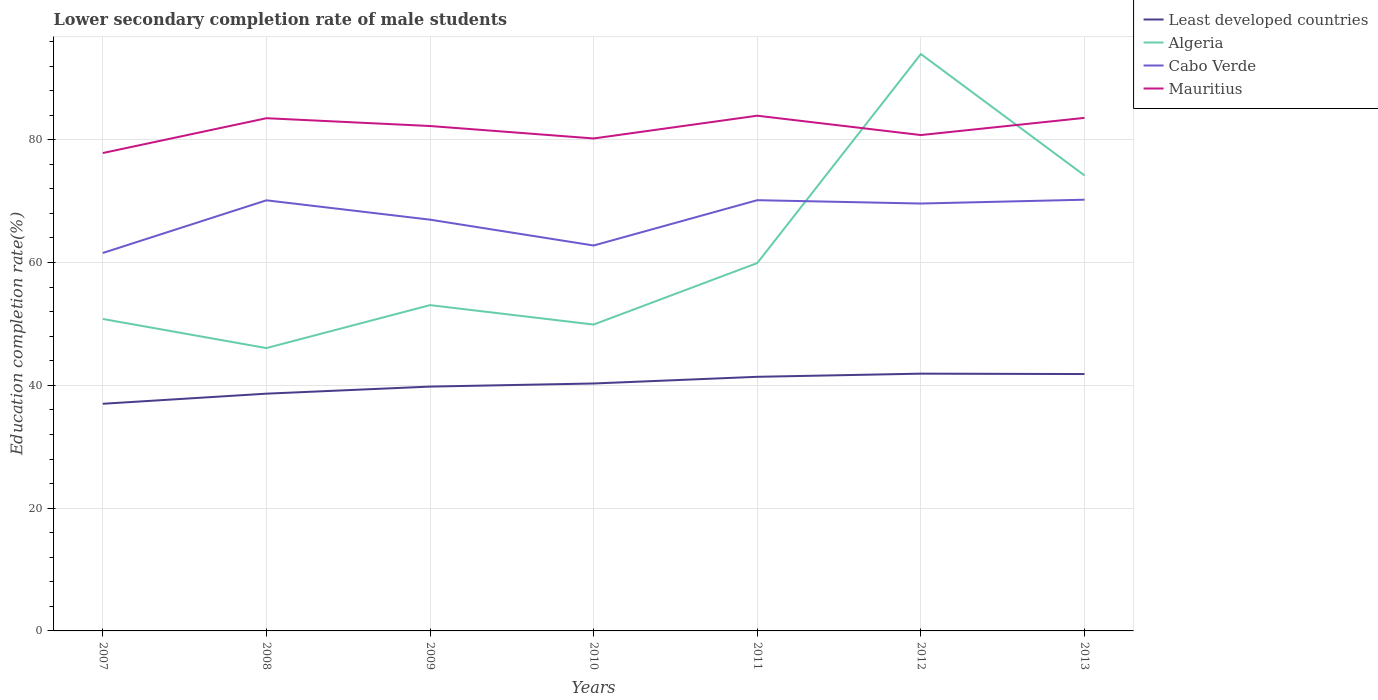Is the number of lines equal to the number of legend labels?
Offer a terse response. Yes. Across all years, what is the maximum lower secondary completion rate of male students in Mauritius?
Keep it short and to the point. 77.83. In which year was the lower secondary completion rate of male students in Algeria maximum?
Keep it short and to the point. 2008. What is the total lower secondary completion rate of male students in Mauritius in the graph?
Make the answer very short. -2.93. What is the difference between the highest and the second highest lower secondary completion rate of male students in Mauritius?
Give a very brief answer. 6.08. What is the difference between the highest and the lowest lower secondary completion rate of male students in Algeria?
Provide a succinct answer. 2. How many years are there in the graph?
Provide a succinct answer. 7. What is the difference between two consecutive major ticks on the Y-axis?
Offer a very short reply. 20. Are the values on the major ticks of Y-axis written in scientific E-notation?
Offer a terse response. No. Does the graph contain any zero values?
Offer a terse response. No. Does the graph contain grids?
Provide a succinct answer. Yes. Where does the legend appear in the graph?
Make the answer very short. Top right. How many legend labels are there?
Keep it short and to the point. 4. What is the title of the graph?
Offer a terse response. Lower secondary completion rate of male students. What is the label or title of the Y-axis?
Your response must be concise. Education completion rate(%). What is the Education completion rate(%) in Least developed countries in 2007?
Provide a short and direct response. 37. What is the Education completion rate(%) in Algeria in 2007?
Your answer should be compact. 50.81. What is the Education completion rate(%) of Cabo Verde in 2007?
Provide a short and direct response. 61.55. What is the Education completion rate(%) of Mauritius in 2007?
Your answer should be very brief. 77.83. What is the Education completion rate(%) in Least developed countries in 2008?
Ensure brevity in your answer.  38.64. What is the Education completion rate(%) in Algeria in 2008?
Provide a succinct answer. 46.07. What is the Education completion rate(%) of Cabo Verde in 2008?
Provide a short and direct response. 70.13. What is the Education completion rate(%) of Mauritius in 2008?
Keep it short and to the point. 83.51. What is the Education completion rate(%) of Least developed countries in 2009?
Keep it short and to the point. 39.79. What is the Education completion rate(%) of Algeria in 2009?
Keep it short and to the point. 53.06. What is the Education completion rate(%) of Cabo Verde in 2009?
Provide a succinct answer. 66.98. What is the Education completion rate(%) of Mauritius in 2009?
Your answer should be compact. 82.24. What is the Education completion rate(%) of Least developed countries in 2010?
Keep it short and to the point. 40.3. What is the Education completion rate(%) of Algeria in 2010?
Provide a succinct answer. 49.9. What is the Education completion rate(%) in Cabo Verde in 2010?
Keep it short and to the point. 62.77. What is the Education completion rate(%) of Mauritius in 2010?
Provide a short and direct response. 80.21. What is the Education completion rate(%) of Least developed countries in 2011?
Make the answer very short. 41.39. What is the Education completion rate(%) in Algeria in 2011?
Make the answer very short. 59.91. What is the Education completion rate(%) in Cabo Verde in 2011?
Ensure brevity in your answer.  70.15. What is the Education completion rate(%) in Mauritius in 2011?
Keep it short and to the point. 83.91. What is the Education completion rate(%) of Least developed countries in 2012?
Provide a short and direct response. 41.9. What is the Education completion rate(%) in Algeria in 2012?
Provide a short and direct response. 93.95. What is the Education completion rate(%) of Cabo Verde in 2012?
Ensure brevity in your answer.  69.61. What is the Education completion rate(%) in Mauritius in 2012?
Your response must be concise. 80.76. What is the Education completion rate(%) of Least developed countries in 2013?
Provide a short and direct response. 41.84. What is the Education completion rate(%) of Algeria in 2013?
Offer a very short reply. 74.19. What is the Education completion rate(%) of Cabo Verde in 2013?
Your response must be concise. 70.23. What is the Education completion rate(%) of Mauritius in 2013?
Offer a very short reply. 83.56. Across all years, what is the maximum Education completion rate(%) in Least developed countries?
Provide a succinct answer. 41.9. Across all years, what is the maximum Education completion rate(%) in Algeria?
Provide a succinct answer. 93.95. Across all years, what is the maximum Education completion rate(%) in Cabo Verde?
Your answer should be compact. 70.23. Across all years, what is the maximum Education completion rate(%) of Mauritius?
Ensure brevity in your answer.  83.91. Across all years, what is the minimum Education completion rate(%) in Least developed countries?
Keep it short and to the point. 37. Across all years, what is the minimum Education completion rate(%) of Algeria?
Offer a terse response. 46.07. Across all years, what is the minimum Education completion rate(%) of Cabo Verde?
Offer a terse response. 61.55. Across all years, what is the minimum Education completion rate(%) of Mauritius?
Provide a succinct answer. 77.83. What is the total Education completion rate(%) in Least developed countries in the graph?
Offer a terse response. 280.86. What is the total Education completion rate(%) in Algeria in the graph?
Offer a very short reply. 427.9. What is the total Education completion rate(%) of Cabo Verde in the graph?
Give a very brief answer. 471.44. What is the total Education completion rate(%) in Mauritius in the graph?
Provide a succinct answer. 572.02. What is the difference between the Education completion rate(%) in Least developed countries in 2007 and that in 2008?
Provide a short and direct response. -1.65. What is the difference between the Education completion rate(%) in Algeria in 2007 and that in 2008?
Give a very brief answer. 4.74. What is the difference between the Education completion rate(%) of Cabo Verde in 2007 and that in 2008?
Provide a succinct answer. -8.58. What is the difference between the Education completion rate(%) of Mauritius in 2007 and that in 2008?
Your answer should be compact. -5.67. What is the difference between the Education completion rate(%) of Least developed countries in 2007 and that in 2009?
Provide a succinct answer. -2.8. What is the difference between the Education completion rate(%) of Algeria in 2007 and that in 2009?
Keep it short and to the point. -2.26. What is the difference between the Education completion rate(%) in Cabo Verde in 2007 and that in 2009?
Offer a very short reply. -5.43. What is the difference between the Education completion rate(%) of Mauritius in 2007 and that in 2009?
Give a very brief answer. -4.4. What is the difference between the Education completion rate(%) of Least developed countries in 2007 and that in 2010?
Your answer should be very brief. -3.31. What is the difference between the Education completion rate(%) in Algeria in 2007 and that in 2010?
Offer a very short reply. 0.91. What is the difference between the Education completion rate(%) in Cabo Verde in 2007 and that in 2010?
Keep it short and to the point. -1.22. What is the difference between the Education completion rate(%) of Mauritius in 2007 and that in 2010?
Your response must be concise. -2.38. What is the difference between the Education completion rate(%) in Least developed countries in 2007 and that in 2011?
Make the answer very short. -4.39. What is the difference between the Education completion rate(%) of Algeria in 2007 and that in 2011?
Provide a succinct answer. -9.1. What is the difference between the Education completion rate(%) of Cabo Verde in 2007 and that in 2011?
Give a very brief answer. -8.6. What is the difference between the Education completion rate(%) of Mauritius in 2007 and that in 2011?
Your answer should be compact. -6.08. What is the difference between the Education completion rate(%) of Least developed countries in 2007 and that in 2012?
Offer a very short reply. -4.91. What is the difference between the Education completion rate(%) of Algeria in 2007 and that in 2012?
Provide a succinct answer. -43.15. What is the difference between the Education completion rate(%) in Cabo Verde in 2007 and that in 2012?
Ensure brevity in your answer.  -8.06. What is the difference between the Education completion rate(%) of Mauritius in 2007 and that in 2012?
Offer a very short reply. -2.93. What is the difference between the Education completion rate(%) in Least developed countries in 2007 and that in 2013?
Provide a short and direct response. -4.84. What is the difference between the Education completion rate(%) of Algeria in 2007 and that in 2013?
Provide a succinct answer. -23.38. What is the difference between the Education completion rate(%) of Cabo Verde in 2007 and that in 2013?
Make the answer very short. -8.68. What is the difference between the Education completion rate(%) of Mauritius in 2007 and that in 2013?
Your answer should be compact. -5.73. What is the difference between the Education completion rate(%) in Least developed countries in 2008 and that in 2009?
Give a very brief answer. -1.15. What is the difference between the Education completion rate(%) in Algeria in 2008 and that in 2009?
Provide a short and direct response. -7. What is the difference between the Education completion rate(%) in Cabo Verde in 2008 and that in 2009?
Provide a succinct answer. 3.15. What is the difference between the Education completion rate(%) in Mauritius in 2008 and that in 2009?
Make the answer very short. 1.27. What is the difference between the Education completion rate(%) in Least developed countries in 2008 and that in 2010?
Give a very brief answer. -1.66. What is the difference between the Education completion rate(%) of Algeria in 2008 and that in 2010?
Your answer should be compact. -3.83. What is the difference between the Education completion rate(%) of Cabo Verde in 2008 and that in 2010?
Offer a terse response. 7.36. What is the difference between the Education completion rate(%) of Mauritius in 2008 and that in 2010?
Ensure brevity in your answer.  3.3. What is the difference between the Education completion rate(%) in Least developed countries in 2008 and that in 2011?
Make the answer very short. -2.75. What is the difference between the Education completion rate(%) in Algeria in 2008 and that in 2011?
Provide a short and direct response. -13.85. What is the difference between the Education completion rate(%) of Cabo Verde in 2008 and that in 2011?
Your response must be concise. -0.02. What is the difference between the Education completion rate(%) in Mauritius in 2008 and that in 2011?
Ensure brevity in your answer.  -0.41. What is the difference between the Education completion rate(%) of Least developed countries in 2008 and that in 2012?
Your answer should be compact. -3.26. What is the difference between the Education completion rate(%) of Algeria in 2008 and that in 2012?
Keep it short and to the point. -47.89. What is the difference between the Education completion rate(%) in Cabo Verde in 2008 and that in 2012?
Keep it short and to the point. 0.52. What is the difference between the Education completion rate(%) of Mauritius in 2008 and that in 2012?
Provide a short and direct response. 2.74. What is the difference between the Education completion rate(%) in Least developed countries in 2008 and that in 2013?
Provide a short and direct response. -3.2. What is the difference between the Education completion rate(%) of Algeria in 2008 and that in 2013?
Make the answer very short. -28.13. What is the difference between the Education completion rate(%) of Cabo Verde in 2008 and that in 2013?
Provide a short and direct response. -0.1. What is the difference between the Education completion rate(%) in Mauritius in 2008 and that in 2013?
Offer a terse response. -0.05. What is the difference between the Education completion rate(%) in Least developed countries in 2009 and that in 2010?
Give a very brief answer. -0.51. What is the difference between the Education completion rate(%) of Algeria in 2009 and that in 2010?
Your answer should be very brief. 3.16. What is the difference between the Education completion rate(%) in Cabo Verde in 2009 and that in 2010?
Offer a terse response. 4.21. What is the difference between the Education completion rate(%) in Mauritius in 2009 and that in 2010?
Provide a short and direct response. 2.03. What is the difference between the Education completion rate(%) in Least developed countries in 2009 and that in 2011?
Provide a short and direct response. -1.59. What is the difference between the Education completion rate(%) of Algeria in 2009 and that in 2011?
Ensure brevity in your answer.  -6.85. What is the difference between the Education completion rate(%) of Cabo Verde in 2009 and that in 2011?
Your response must be concise. -3.17. What is the difference between the Education completion rate(%) in Mauritius in 2009 and that in 2011?
Ensure brevity in your answer.  -1.68. What is the difference between the Education completion rate(%) of Least developed countries in 2009 and that in 2012?
Offer a terse response. -2.11. What is the difference between the Education completion rate(%) in Algeria in 2009 and that in 2012?
Ensure brevity in your answer.  -40.89. What is the difference between the Education completion rate(%) of Cabo Verde in 2009 and that in 2012?
Offer a terse response. -2.63. What is the difference between the Education completion rate(%) of Mauritius in 2009 and that in 2012?
Your response must be concise. 1.47. What is the difference between the Education completion rate(%) of Least developed countries in 2009 and that in 2013?
Offer a very short reply. -2.04. What is the difference between the Education completion rate(%) in Algeria in 2009 and that in 2013?
Offer a terse response. -21.13. What is the difference between the Education completion rate(%) in Cabo Verde in 2009 and that in 2013?
Your answer should be compact. -3.25. What is the difference between the Education completion rate(%) in Mauritius in 2009 and that in 2013?
Offer a very short reply. -1.32. What is the difference between the Education completion rate(%) in Least developed countries in 2010 and that in 2011?
Offer a terse response. -1.09. What is the difference between the Education completion rate(%) of Algeria in 2010 and that in 2011?
Provide a short and direct response. -10.01. What is the difference between the Education completion rate(%) of Cabo Verde in 2010 and that in 2011?
Ensure brevity in your answer.  -7.38. What is the difference between the Education completion rate(%) in Mauritius in 2010 and that in 2011?
Ensure brevity in your answer.  -3.71. What is the difference between the Education completion rate(%) in Least developed countries in 2010 and that in 2012?
Offer a very short reply. -1.6. What is the difference between the Education completion rate(%) in Algeria in 2010 and that in 2012?
Provide a short and direct response. -44.05. What is the difference between the Education completion rate(%) in Cabo Verde in 2010 and that in 2012?
Keep it short and to the point. -6.84. What is the difference between the Education completion rate(%) in Mauritius in 2010 and that in 2012?
Provide a succinct answer. -0.56. What is the difference between the Education completion rate(%) of Least developed countries in 2010 and that in 2013?
Ensure brevity in your answer.  -1.54. What is the difference between the Education completion rate(%) of Algeria in 2010 and that in 2013?
Provide a succinct answer. -24.29. What is the difference between the Education completion rate(%) of Cabo Verde in 2010 and that in 2013?
Give a very brief answer. -7.46. What is the difference between the Education completion rate(%) of Mauritius in 2010 and that in 2013?
Give a very brief answer. -3.35. What is the difference between the Education completion rate(%) of Least developed countries in 2011 and that in 2012?
Provide a succinct answer. -0.51. What is the difference between the Education completion rate(%) in Algeria in 2011 and that in 2012?
Your response must be concise. -34.04. What is the difference between the Education completion rate(%) of Cabo Verde in 2011 and that in 2012?
Give a very brief answer. 0.54. What is the difference between the Education completion rate(%) of Mauritius in 2011 and that in 2012?
Offer a very short reply. 3.15. What is the difference between the Education completion rate(%) in Least developed countries in 2011 and that in 2013?
Make the answer very short. -0.45. What is the difference between the Education completion rate(%) in Algeria in 2011 and that in 2013?
Ensure brevity in your answer.  -14.28. What is the difference between the Education completion rate(%) of Cabo Verde in 2011 and that in 2013?
Offer a terse response. -0.08. What is the difference between the Education completion rate(%) of Mauritius in 2011 and that in 2013?
Keep it short and to the point. 0.35. What is the difference between the Education completion rate(%) in Least developed countries in 2012 and that in 2013?
Keep it short and to the point. 0.06. What is the difference between the Education completion rate(%) in Algeria in 2012 and that in 2013?
Provide a succinct answer. 19.76. What is the difference between the Education completion rate(%) of Cabo Verde in 2012 and that in 2013?
Your response must be concise. -0.62. What is the difference between the Education completion rate(%) in Mauritius in 2012 and that in 2013?
Your answer should be compact. -2.8. What is the difference between the Education completion rate(%) of Least developed countries in 2007 and the Education completion rate(%) of Algeria in 2008?
Ensure brevity in your answer.  -9.07. What is the difference between the Education completion rate(%) of Least developed countries in 2007 and the Education completion rate(%) of Cabo Verde in 2008?
Offer a terse response. -33.14. What is the difference between the Education completion rate(%) of Least developed countries in 2007 and the Education completion rate(%) of Mauritius in 2008?
Your response must be concise. -46.51. What is the difference between the Education completion rate(%) of Algeria in 2007 and the Education completion rate(%) of Cabo Verde in 2008?
Your answer should be compact. -19.32. What is the difference between the Education completion rate(%) of Algeria in 2007 and the Education completion rate(%) of Mauritius in 2008?
Your answer should be compact. -32.7. What is the difference between the Education completion rate(%) of Cabo Verde in 2007 and the Education completion rate(%) of Mauritius in 2008?
Provide a short and direct response. -21.95. What is the difference between the Education completion rate(%) in Least developed countries in 2007 and the Education completion rate(%) in Algeria in 2009?
Your response must be concise. -16.07. What is the difference between the Education completion rate(%) of Least developed countries in 2007 and the Education completion rate(%) of Cabo Verde in 2009?
Offer a terse response. -29.99. What is the difference between the Education completion rate(%) in Least developed countries in 2007 and the Education completion rate(%) in Mauritius in 2009?
Offer a very short reply. -45.24. What is the difference between the Education completion rate(%) in Algeria in 2007 and the Education completion rate(%) in Cabo Verde in 2009?
Your response must be concise. -16.17. What is the difference between the Education completion rate(%) of Algeria in 2007 and the Education completion rate(%) of Mauritius in 2009?
Provide a short and direct response. -31.43. What is the difference between the Education completion rate(%) of Cabo Verde in 2007 and the Education completion rate(%) of Mauritius in 2009?
Provide a short and direct response. -20.68. What is the difference between the Education completion rate(%) of Least developed countries in 2007 and the Education completion rate(%) of Algeria in 2010?
Your response must be concise. -12.9. What is the difference between the Education completion rate(%) of Least developed countries in 2007 and the Education completion rate(%) of Cabo Verde in 2010?
Your answer should be compact. -25.78. What is the difference between the Education completion rate(%) in Least developed countries in 2007 and the Education completion rate(%) in Mauritius in 2010?
Provide a short and direct response. -43.21. What is the difference between the Education completion rate(%) of Algeria in 2007 and the Education completion rate(%) of Cabo Verde in 2010?
Your answer should be very brief. -11.97. What is the difference between the Education completion rate(%) of Algeria in 2007 and the Education completion rate(%) of Mauritius in 2010?
Provide a succinct answer. -29.4. What is the difference between the Education completion rate(%) in Cabo Verde in 2007 and the Education completion rate(%) in Mauritius in 2010?
Your response must be concise. -18.65. What is the difference between the Education completion rate(%) of Least developed countries in 2007 and the Education completion rate(%) of Algeria in 2011?
Offer a terse response. -22.92. What is the difference between the Education completion rate(%) in Least developed countries in 2007 and the Education completion rate(%) in Cabo Verde in 2011?
Keep it short and to the point. -33.16. What is the difference between the Education completion rate(%) of Least developed countries in 2007 and the Education completion rate(%) of Mauritius in 2011?
Give a very brief answer. -46.92. What is the difference between the Education completion rate(%) of Algeria in 2007 and the Education completion rate(%) of Cabo Verde in 2011?
Ensure brevity in your answer.  -19.35. What is the difference between the Education completion rate(%) of Algeria in 2007 and the Education completion rate(%) of Mauritius in 2011?
Provide a short and direct response. -33.11. What is the difference between the Education completion rate(%) of Cabo Verde in 2007 and the Education completion rate(%) of Mauritius in 2011?
Offer a very short reply. -22.36. What is the difference between the Education completion rate(%) of Least developed countries in 2007 and the Education completion rate(%) of Algeria in 2012?
Make the answer very short. -56.96. What is the difference between the Education completion rate(%) of Least developed countries in 2007 and the Education completion rate(%) of Cabo Verde in 2012?
Provide a succinct answer. -32.61. What is the difference between the Education completion rate(%) of Least developed countries in 2007 and the Education completion rate(%) of Mauritius in 2012?
Your response must be concise. -43.77. What is the difference between the Education completion rate(%) of Algeria in 2007 and the Education completion rate(%) of Cabo Verde in 2012?
Keep it short and to the point. -18.8. What is the difference between the Education completion rate(%) in Algeria in 2007 and the Education completion rate(%) in Mauritius in 2012?
Make the answer very short. -29.96. What is the difference between the Education completion rate(%) in Cabo Verde in 2007 and the Education completion rate(%) in Mauritius in 2012?
Offer a very short reply. -19.21. What is the difference between the Education completion rate(%) in Least developed countries in 2007 and the Education completion rate(%) in Algeria in 2013?
Offer a very short reply. -37.2. What is the difference between the Education completion rate(%) in Least developed countries in 2007 and the Education completion rate(%) in Cabo Verde in 2013?
Provide a succinct answer. -33.24. What is the difference between the Education completion rate(%) of Least developed countries in 2007 and the Education completion rate(%) of Mauritius in 2013?
Keep it short and to the point. -46.56. What is the difference between the Education completion rate(%) in Algeria in 2007 and the Education completion rate(%) in Cabo Verde in 2013?
Your response must be concise. -19.42. What is the difference between the Education completion rate(%) in Algeria in 2007 and the Education completion rate(%) in Mauritius in 2013?
Offer a terse response. -32.75. What is the difference between the Education completion rate(%) in Cabo Verde in 2007 and the Education completion rate(%) in Mauritius in 2013?
Provide a short and direct response. -22.01. What is the difference between the Education completion rate(%) of Least developed countries in 2008 and the Education completion rate(%) of Algeria in 2009?
Give a very brief answer. -14.42. What is the difference between the Education completion rate(%) in Least developed countries in 2008 and the Education completion rate(%) in Cabo Verde in 2009?
Provide a short and direct response. -28.34. What is the difference between the Education completion rate(%) of Least developed countries in 2008 and the Education completion rate(%) of Mauritius in 2009?
Your response must be concise. -43.59. What is the difference between the Education completion rate(%) in Algeria in 2008 and the Education completion rate(%) in Cabo Verde in 2009?
Your response must be concise. -20.92. What is the difference between the Education completion rate(%) of Algeria in 2008 and the Education completion rate(%) of Mauritius in 2009?
Make the answer very short. -36.17. What is the difference between the Education completion rate(%) in Cabo Verde in 2008 and the Education completion rate(%) in Mauritius in 2009?
Provide a succinct answer. -12.1. What is the difference between the Education completion rate(%) in Least developed countries in 2008 and the Education completion rate(%) in Algeria in 2010?
Keep it short and to the point. -11.26. What is the difference between the Education completion rate(%) in Least developed countries in 2008 and the Education completion rate(%) in Cabo Verde in 2010?
Offer a terse response. -24.13. What is the difference between the Education completion rate(%) of Least developed countries in 2008 and the Education completion rate(%) of Mauritius in 2010?
Give a very brief answer. -41.57. What is the difference between the Education completion rate(%) in Algeria in 2008 and the Education completion rate(%) in Cabo Verde in 2010?
Offer a very short reply. -16.71. What is the difference between the Education completion rate(%) in Algeria in 2008 and the Education completion rate(%) in Mauritius in 2010?
Offer a very short reply. -34.14. What is the difference between the Education completion rate(%) in Cabo Verde in 2008 and the Education completion rate(%) in Mauritius in 2010?
Make the answer very short. -10.08. What is the difference between the Education completion rate(%) in Least developed countries in 2008 and the Education completion rate(%) in Algeria in 2011?
Keep it short and to the point. -21.27. What is the difference between the Education completion rate(%) in Least developed countries in 2008 and the Education completion rate(%) in Cabo Verde in 2011?
Your answer should be compact. -31.51. What is the difference between the Education completion rate(%) of Least developed countries in 2008 and the Education completion rate(%) of Mauritius in 2011?
Ensure brevity in your answer.  -45.27. What is the difference between the Education completion rate(%) of Algeria in 2008 and the Education completion rate(%) of Cabo Verde in 2011?
Provide a succinct answer. -24.09. What is the difference between the Education completion rate(%) in Algeria in 2008 and the Education completion rate(%) in Mauritius in 2011?
Ensure brevity in your answer.  -37.85. What is the difference between the Education completion rate(%) of Cabo Verde in 2008 and the Education completion rate(%) of Mauritius in 2011?
Offer a very short reply. -13.78. What is the difference between the Education completion rate(%) of Least developed countries in 2008 and the Education completion rate(%) of Algeria in 2012?
Your response must be concise. -55.31. What is the difference between the Education completion rate(%) of Least developed countries in 2008 and the Education completion rate(%) of Cabo Verde in 2012?
Your answer should be very brief. -30.97. What is the difference between the Education completion rate(%) of Least developed countries in 2008 and the Education completion rate(%) of Mauritius in 2012?
Your response must be concise. -42.12. What is the difference between the Education completion rate(%) of Algeria in 2008 and the Education completion rate(%) of Cabo Verde in 2012?
Your answer should be very brief. -23.54. What is the difference between the Education completion rate(%) in Algeria in 2008 and the Education completion rate(%) in Mauritius in 2012?
Give a very brief answer. -34.7. What is the difference between the Education completion rate(%) in Cabo Verde in 2008 and the Education completion rate(%) in Mauritius in 2012?
Keep it short and to the point. -10.63. What is the difference between the Education completion rate(%) in Least developed countries in 2008 and the Education completion rate(%) in Algeria in 2013?
Your response must be concise. -35.55. What is the difference between the Education completion rate(%) in Least developed countries in 2008 and the Education completion rate(%) in Cabo Verde in 2013?
Provide a short and direct response. -31.59. What is the difference between the Education completion rate(%) of Least developed countries in 2008 and the Education completion rate(%) of Mauritius in 2013?
Your answer should be very brief. -44.92. What is the difference between the Education completion rate(%) of Algeria in 2008 and the Education completion rate(%) of Cabo Verde in 2013?
Your answer should be very brief. -24.17. What is the difference between the Education completion rate(%) in Algeria in 2008 and the Education completion rate(%) in Mauritius in 2013?
Your answer should be compact. -37.49. What is the difference between the Education completion rate(%) in Cabo Verde in 2008 and the Education completion rate(%) in Mauritius in 2013?
Offer a terse response. -13.43. What is the difference between the Education completion rate(%) of Least developed countries in 2009 and the Education completion rate(%) of Algeria in 2010?
Offer a very short reply. -10.11. What is the difference between the Education completion rate(%) in Least developed countries in 2009 and the Education completion rate(%) in Cabo Verde in 2010?
Give a very brief answer. -22.98. What is the difference between the Education completion rate(%) in Least developed countries in 2009 and the Education completion rate(%) in Mauritius in 2010?
Your answer should be compact. -40.42. What is the difference between the Education completion rate(%) of Algeria in 2009 and the Education completion rate(%) of Cabo Verde in 2010?
Keep it short and to the point. -9.71. What is the difference between the Education completion rate(%) of Algeria in 2009 and the Education completion rate(%) of Mauritius in 2010?
Keep it short and to the point. -27.14. What is the difference between the Education completion rate(%) in Cabo Verde in 2009 and the Education completion rate(%) in Mauritius in 2010?
Provide a succinct answer. -13.23. What is the difference between the Education completion rate(%) in Least developed countries in 2009 and the Education completion rate(%) in Algeria in 2011?
Your answer should be very brief. -20.12. What is the difference between the Education completion rate(%) in Least developed countries in 2009 and the Education completion rate(%) in Cabo Verde in 2011?
Your answer should be very brief. -30.36. What is the difference between the Education completion rate(%) in Least developed countries in 2009 and the Education completion rate(%) in Mauritius in 2011?
Give a very brief answer. -44.12. What is the difference between the Education completion rate(%) of Algeria in 2009 and the Education completion rate(%) of Cabo Verde in 2011?
Give a very brief answer. -17.09. What is the difference between the Education completion rate(%) of Algeria in 2009 and the Education completion rate(%) of Mauritius in 2011?
Offer a terse response. -30.85. What is the difference between the Education completion rate(%) in Cabo Verde in 2009 and the Education completion rate(%) in Mauritius in 2011?
Provide a short and direct response. -16.93. What is the difference between the Education completion rate(%) in Least developed countries in 2009 and the Education completion rate(%) in Algeria in 2012?
Keep it short and to the point. -54.16. What is the difference between the Education completion rate(%) in Least developed countries in 2009 and the Education completion rate(%) in Cabo Verde in 2012?
Your answer should be compact. -29.82. What is the difference between the Education completion rate(%) of Least developed countries in 2009 and the Education completion rate(%) of Mauritius in 2012?
Make the answer very short. -40.97. What is the difference between the Education completion rate(%) of Algeria in 2009 and the Education completion rate(%) of Cabo Verde in 2012?
Ensure brevity in your answer.  -16.55. What is the difference between the Education completion rate(%) of Algeria in 2009 and the Education completion rate(%) of Mauritius in 2012?
Your answer should be compact. -27.7. What is the difference between the Education completion rate(%) in Cabo Verde in 2009 and the Education completion rate(%) in Mauritius in 2012?
Your response must be concise. -13.78. What is the difference between the Education completion rate(%) in Least developed countries in 2009 and the Education completion rate(%) in Algeria in 2013?
Keep it short and to the point. -34.4. What is the difference between the Education completion rate(%) of Least developed countries in 2009 and the Education completion rate(%) of Cabo Verde in 2013?
Ensure brevity in your answer.  -30.44. What is the difference between the Education completion rate(%) of Least developed countries in 2009 and the Education completion rate(%) of Mauritius in 2013?
Provide a short and direct response. -43.77. What is the difference between the Education completion rate(%) in Algeria in 2009 and the Education completion rate(%) in Cabo Verde in 2013?
Give a very brief answer. -17.17. What is the difference between the Education completion rate(%) of Algeria in 2009 and the Education completion rate(%) of Mauritius in 2013?
Offer a very short reply. -30.5. What is the difference between the Education completion rate(%) of Cabo Verde in 2009 and the Education completion rate(%) of Mauritius in 2013?
Your answer should be very brief. -16.58. What is the difference between the Education completion rate(%) of Least developed countries in 2010 and the Education completion rate(%) of Algeria in 2011?
Provide a succinct answer. -19.61. What is the difference between the Education completion rate(%) of Least developed countries in 2010 and the Education completion rate(%) of Cabo Verde in 2011?
Provide a succinct answer. -29.85. What is the difference between the Education completion rate(%) in Least developed countries in 2010 and the Education completion rate(%) in Mauritius in 2011?
Offer a terse response. -43.61. What is the difference between the Education completion rate(%) in Algeria in 2010 and the Education completion rate(%) in Cabo Verde in 2011?
Offer a terse response. -20.25. What is the difference between the Education completion rate(%) of Algeria in 2010 and the Education completion rate(%) of Mauritius in 2011?
Your answer should be compact. -34.01. What is the difference between the Education completion rate(%) of Cabo Verde in 2010 and the Education completion rate(%) of Mauritius in 2011?
Your response must be concise. -21.14. What is the difference between the Education completion rate(%) in Least developed countries in 2010 and the Education completion rate(%) in Algeria in 2012?
Provide a succinct answer. -53.65. What is the difference between the Education completion rate(%) of Least developed countries in 2010 and the Education completion rate(%) of Cabo Verde in 2012?
Ensure brevity in your answer.  -29.31. What is the difference between the Education completion rate(%) of Least developed countries in 2010 and the Education completion rate(%) of Mauritius in 2012?
Your answer should be very brief. -40.46. What is the difference between the Education completion rate(%) in Algeria in 2010 and the Education completion rate(%) in Cabo Verde in 2012?
Keep it short and to the point. -19.71. What is the difference between the Education completion rate(%) of Algeria in 2010 and the Education completion rate(%) of Mauritius in 2012?
Offer a terse response. -30.86. What is the difference between the Education completion rate(%) in Cabo Verde in 2010 and the Education completion rate(%) in Mauritius in 2012?
Give a very brief answer. -17.99. What is the difference between the Education completion rate(%) in Least developed countries in 2010 and the Education completion rate(%) in Algeria in 2013?
Ensure brevity in your answer.  -33.89. What is the difference between the Education completion rate(%) of Least developed countries in 2010 and the Education completion rate(%) of Cabo Verde in 2013?
Offer a very short reply. -29.93. What is the difference between the Education completion rate(%) of Least developed countries in 2010 and the Education completion rate(%) of Mauritius in 2013?
Your response must be concise. -43.26. What is the difference between the Education completion rate(%) of Algeria in 2010 and the Education completion rate(%) of Cabo Verde in 2013?
Your answer should be very brief. -20.33. What is the difference between the Education completion rate(%) in Algeria in 2010 and the Education completion rate(%) in Mauritius in 2013?
Make the answer very short. -33.66. What is the difference between the Education completion rate(%) of Cabo Verde in 2010 and the Education completion rate(%) of Mauritius in 2013?
Provide a short and direct response. -20.79. What is the difference between the Education completion rate(%) of Least developed countries in 2011 and the Education completion rate(%) of Algeria in 2012?
Make the answer very short. -52.57. What is the difference between the Education completion rate(%) of Least developed countries in 2011 and the Education completion rate(%) of Cabo Verde in 2012?
Your response must be concise. -28.22. What is the difference between the Education completion rate(%) of Least developed countries in 2011 and the Education completion rate(%) of Mauritius in 2012?
Keep it short and to the point. -39.38. What is the difference between the Education completion rate(%) of Algeria in 2011 and the Education completion rate(%) of Cabo Verde in 2012?
Make the answer very short. -9.7. What is the difference between the Education completion rate(%) in Algeria in 2011 and the Education completion rate(%) in Mauritius in 2012?
Offer a very short reply. -20.85. What is the difference between the Education completion rate(%) of Cabo Verde in 2011 and the Education completion rate(%) of Mauritius in 2012?
Offer a terse response. -10.61. What is the difference between the Education completion rate(%) of Least developed countries in 2011 and the Education completion rate(%) of Algeria in 2013?
Give a very brief answer. -32.8. What is the difference between the Education completion rate(%) of Least developed countries in 2011 and the Education completion rate(%) of Cabo Verde in 2013?
Make the answer very short. -28.84. What is the difference between the Education completion rate(%) of Least developed countries in 2011 and the Education completion rate(%) of Mauritius in 2013?
Make the answer very short. -42.17. What is the difference between the Education completion rate(%) of Algeria in 2011 and the Education completion rate(%) of Cabo Verde in 2013?
Make the answer very short. -10.32. What is the difference between the Education completion rate(%) of Algeria in 2011 and the Education completion rate(%) of Mauritius in 2013?
Offer a terse response. -23.65. What is the difference between the Education completion rate(%) in Cabo Verde in 2011 and the Education completion rate(%) in Mauritius in 2013?
Your answer should be compact. -13.41. What is the difference between the Education completion rate(%) in Least developed countries in 2012 and the Education completion rate(%) in Algeria in 2013?
Your answer should be very brief. -32.29. What is the difference between the Education completion rate(%) of Least developed countries in 2012 and the Education completion rate(%) of Cabo Verde in 2013?
Provide a succinct answer. -28.33. What is the difference between the Education completion rate(%) of Least developed countries in 2012 and the Education completion rate(%) of Mauritius in 2013?
Provide a short and direct response. -41.66. What is the difference between the Education completion rate(%) of Algeria in 2012 and the Education completion rate(%) of Cabo Verde in 2013?
Offer a terse response. 23.72. What is the difference between the Education completion rate(%) of Algeria in 2012 and the Education completion rate(%) of Mauritius in 2013?
Keep it short and to the point. 10.39. What is the difference between the Education completion rate(%) in Cabo Verde in 2012 and the Education completion rate(%) in Mauritius in 2013?
Offer a very short reply. -13.95. What is the average Education completion rate(%) of Least developed countries per year?
Your answer should be very brief. 40.12. What is the average Education completion rate(%) of Algeria per year?
Give a very brief answer. 61.13. What is the average Education completion rate(%) of Cabo Verde per year?
Your answer should be very brief. 67.35. What is the average Education completion rate(%) of Mauritius per year?
Your answer should be compact. 81.72. In the year 2007, what is the difference between the Education completion rate(%) in Least developed countries and Education completion rate(%) in Algeria?
Give a very brief answer. -13.81. In the year 2007, what is the difference between the Education completion rate(%) in Least developed countries and Education completion rate(%) in Cabo Verde?
Provide a short and direct response. -24.56. In the year 2007, what is the difference between the Education completion rate(%) in Least developed countries and Education completion rate(%) in Mauritius?
Provide a short and direct response. -40.84. In the year 2007, what is the difference between the Education completion rate(%) in Algeria and Education completion rate(%) in Cabo Verde?
Provide a short and direct response. -10.75. In the year 2007, what is the difference between the Education completion rate(%) in Algeria and Education completion rate(%) in Mauritius?
Keep it short and to the point. -27.03. In the year 2007, what is the difference between the Education completion rate(%) of Cabo Verde and Education completion rate(%) of Mauritius?
Keep it short and to the point. -16.28. In the year 2008, what is the difference between the Education completion rate(%) of Least developed countries and Education completion rate(%) of Algeria?
Provide a short and direct response. -7.42. In the year 2008, what is the difference between the Education completion rate(%) in Least developed countries and Education completion rate(%) in Cabo Verde?
Your answer should be compact. -31.49. In the year 2008, what is the difference between the Education completion rate(%) in Least developed countries and Education completion rate(%) in Mauritius?
Make the answer very short. -44.86. In the year 2008, what is the difference between the Education completion rate(%) in Algeria and Education completion rate(%) in Cabo Verde?
Give a very brief answer. -24.07. In the year 2008, what is the difference between the Education completion rate(%) in Algeria and Education completion rate(%) in Mauritius?
Provide a succinct answer. -37.44. In the year 2008, what is the difference between the Education completion rate(%) of Cabo Verde and Education completion rate(%) of Mauritius?
Your answer should be compact. -13.37. In the year 2009, what is the difference between the Education completion rate(%) in Least developed countries and Education completion rate(%) in Algeria?
Give a very brief answer. -13.27. In the year 2009, what is the difference between the Education completion rate(%) in Least developed countries and Education completion rate(%) in Cabo Verde?
Your answer should be very brief. -27.19. In the year 2009, what is the difference between the Education completion rate(%) of Least developed countries and Education completion rate(%) of Mauritius?
Offer a very short reply. -42.44. In the year 2009, what is the difference between the Education completion rate(%) of Algeria and Education completion rate(%) of Cabo Verde?
Provide a succinct answer. -13.92. In the year 2009, what is the difference between the Education completion rate(%) in Algeria and Education completion rate(%) in Mauritius?
Make the answer very short. -29.17. In the year 2009, what is the difference between the Education completion rate(%) in Cabo Verde and Education completion rate(%) in Mauritius?
Offer a very short reply. -15.25. In the year 2010, what is the difference between the Education completion rate(%) in Least developed countries and Education completion rate(%) in Algeria?
Provide a short and direct response. -9.6. In the year 2010, what is the difference between the Education completion rate(%) in Least developed countries and Education completion rate(%) in Cabo Verde?
Give a very brief answer. -22.47. In the year 2010, what is the difference between the Education completion rate(%) in Least developed countries and Education completion rate(%) in Mauritius?
Give a very brief answer. -39.91. In the year 2010, what is the difference between the Education completion rate(%) of Algeria and Education completion rate(%) of Cabo Verde?
Your response must be concise. -12.87. In the year 2010, what is the difference between the Education completion rate(%) of Algeria and Education completion rate(%) of Mauritius?
Ensure brevity in your answer.  -30.31. In the year 2010, what is the difference between the Education completion rate(%) of Cabo Verde and Education completion rate(%) of Mauritius?
Make the answer very short. -17.44. In the year 2011, what is the difference between the Education completion rate(%) of Least developed countries and Education completion rate(%) of Algeria?
Give a very brief answer. -18.52. In the year 2011, what is the difference between the Education completion rate(%) in Least developed countries and Education completion rate(%) in Cabo Verde?
Give a very brief answer. -28.77. In the year 2011, what is the difference between the Education completion rate(%) in Least developed countries and Education completion rate(%) in Mauritius?
Make the answer very short. -42.53. In the year 2011, what is the difference between the Education completion rate(%) in Algeria and Education completion rate(%) in Cabo Verde?
Ensure brevity in your answer.  -10.24. In the year 2011, what is the difference between the Education completion rate(%) in Algeria and Education completion rate(%) in Mauritius?
Provide a short and direct response. -24. In the year 2011, what is the difference between the Education completion rate(%) in Cabo Verde and Education completion rate(%) in Mauritius?
Ensure brevity in your answer.  -13.76. In the year 2012, what is the difference between the Education completion rate(%) of Least developed countries and Education completion rate(%) of Algeria?
Your response must be concise. -52.05. In the year 2012, what is the difference between the Education completion rate(%) in Least developed countries and Education completion rate(%) in Cabo Verde?
Your answer should be very brief. -27.71. In the year 2012, what is the difference between the Education completion rate(%) in Least developed countries and Education completion rate(%) in Mauritius?
Your response must be concise. -38.86. In the year 2012, what is the difference between the Education completion rate(%) in Algeria and Education completion rate(%) in Cabo Verde?
Offer a terse response. 24.34. In the year 2012, what is the difference between the Education completion rate(%) of Algeria and Education completion rate(%) of Mauritius?
Keep it short and to the point. 13.19. In the year 2012, what is the difference between the Education completion rate(%) in Cabo Verde and Education completion rate(%) in Mauritius?
Offer a very short reply. -11.15. In the year 2013, what is the difference between the Education completion rate(%) of Least developed countries and Education completion rate(%) of Algeria?
Your response must be concise. -32.35. In the year 2013, what is the difference between the Education completion rate(%) of Least developed countries and Education completion rate(%) of Cabo Verde?
Make the answer very short. -28.39. In the year 2013, what is the difference between the Education completion rate(%) of Least developed countries and Education completion rate(%) of Mauritius?
Provide a succinct answer. -41.72. In the year 2013, what is the difference between the Education completion rate(%) in Algeria and Education completion rate(%) in Cabo Verde?
Your answer should be compact. 3.96. In the year 2013, what is the difference between the Education completion rate(%) of Algeria and Education completion rate(%) of Mauritius?
Give a very brief answer. -9.37. In the year 2013, what is the difference between the Education completion rate(%) of Cabo Verde and Education completion rate(%) of Mauritius?
Ensure brevity in your answer.  -13.33. What is the ratio of the Education completion rate(%) of Least developed countries in 2007 to that in 2008?
Offer a very short reply. 0.96. What is the ratio of the Education completion rate(%) of Algeria in 2007 to that in 2008?
Your response must be concise. 1.1. What is the ratio of the Education completion rate(%) of Cabo Verde in 2007 to that in 2008?
Your answer should be compact. 0.88. What is the ratio of the Education completion rate(%) in Mauritius in 2007 to that in 2008?
Keep it short and to the point. 0.93. What is the ratio of the Education completion rate(%) in Least developed countries in 2007 to that in 2009?
Ensure brevity in your answer.  0.93. What is the ratio of the Education completion rate(%) of Algeria in 2007 to that in 2009?
Give a very brief answer. 0.96. What is the ratio of the Education completion rate(%) of Cabo Verde in 2007 to that in 2009?
Provide a succinct answer. 0.92. What is the ratio of the Education completion rate(%) of Mauritius in 2007 to that in 2009?
Keep it short and to the point. 0.95. What is the ratio of the Education completion rate(%) in Least developed countries in 2007 to that in 2010?
Keep it short and to the point. 0.92. What is the ratio of the Education completion rate(%) in Algeria in 2007 to that in 2010?
Keep it short and to the point. 1.02. What is the ratio of the Education completion rate(%) of Cabo Verde in 2007 to that in 2010?
Offer a terse response. 0.98. What is the ratio of the Education completion rate(%) of Mauritius in 2007 to that in 2010?
Your answer should be compact. 0.97. What is the ratio of the Education completion rate(%) in Least developed countries in 2007 to that in 2011?
Provide a succinct answer. 0.89. What is the ratio of the Education completion rate(%) of Algeria in 2007 to that in 2011?
Your answer should be very brief. 0.85. What is the ratio of the Education completion rate(%) of Cabo Verde in 2007 to that in 2011?
Offer a terse response. 0.88. What is the ratio of the Education completion rate(%) of Mauritius in 2007 to that in 2011?
Keep it short and to the point. 0.93. What is the ratio of the Education completion rate(%) in Least developed countries in 2007 to that in 2012?
Your answer should be very brief. 0.88. What is the ratio of the Education completion rate(%) in Algeria in 2007 to that in 2012?
Make the answer very short. 0.54. What is the ratio of the Education completion rate(%) in Cabo Verde in 2007 to that in 2012?
Give a very brief answer. 0.88. What is the ratio of the Education completion rate(%) of Mauritius in 2007 to that in 2012?
Keep it short and to the point. 0.96. What is the ratio of the Education completion rate(%) in Least developed countries in 2007 to that in 2013?
Give a very brief answer. 0.88. What is the ratio of the Education completion rate(%) of Algeria in 2007 to that in 2013?
Ensure brevity in your answer.  0.68. What is the ratio of the Education completion rate(%) in Cabo Verde in 2007 to that in 2013?
Your response must be concise. 0.88. What is the ratio of the Education completion rate(%) in Mauritius in 2007 to that in 2013?
Offer a very short reply. 0.93. What is the ratio of the Education completion rate(%) of Least developed countries in 2008 to that in 2009?
Ensure brevity in your answer.  0.97. What is the ratio of the Education completion rate(%) in Algeria in 2008 to that in 2009?
Make the answer very short. 0.87. What is the ratio of the Education completion rate(%) of Cabo Verde in 2008 to that in 2009?
Your answer should be very brief. 1.05. What is the ratio of the Education completion rate(%) in Mauritius in 2008 to that in 2009?
Provide a short and direct response. 1.02. What is the ratio of the Education completion rate(%) in Least developed countries in 2008 to that in 2010?
Your answer should be compact. 0.96. What is the ratio of the Education completion rate(%) of Algeria in 2008 to that in 2010?
Provide a short and direct response. 0.92. What is the ratio of the Education completion rate(%) of Cabo Verde in 2008 to that in 2010?
Make the answer very short. 1.12. What is the ratio of the Education completion rate(%) in Mauritius in 2008 to that in 2010?
Provide a succinct answer. 1.04. What is the ratio of the Education completion rate(%) of Least developed countries in 2008 to that in 2011?
Offer a very short reply. 0.93. What is the ratio of the Education completion rate(%) in Algeria in 2008 to that in 2011?
Keep it short and to the point. 0.77. What is the ratio of the Education completion rate(%) in Mauritius in 2008 to that in 2011?
Give a very brief answer. 1. What is the ratio of the Education completion rate(%) of Least developed countries in 2008 to that in 2012?
Offer a very short reply. 0.92. What is the ratio of the Education completion rate(%) in Algeria in 2008 to that in 2012?
Keep it short and to the point. 0.49. What is the ratio of the Education completion rate(%) of Cabo Verde in 2008 to that in 2012?
Keep it short and to the point. 1.01. What is the ratio of the Education completion rate(%) in Mauritius in 2008 to that in 2012?
Your response must be concise. 1.03. What is the ratio of the Education completion rate(%) of Least developed countries in 2008 to that in 2013?
Give a very brief answer. 0.92. What is the ratio of the Education completion rate(%) in Algeria in 2008 to that in 2013?
Make the answer very short. 0.62. What is the ratio of the Education completion rate(%) in Least developed countries in 2009 to that in 2010?
Keep it short and to the point. 0.99. What is the ratio of the Education completion rate(%) in Algeria in 2009 to that in 2010?
Your answer should be compact. 1.06. What is the ratio of the Education completion rate(%) of Cabo Verde in 2009 to that in 2010?
Ensure brevity in your answer.  1.07. What is the ratio of the Education completion rate(%) in Mauritius in 2009 to that in 2010?
Offer a very short reply. 1.03. What is the ratio of the Education completion rate(%) in Least developed countries in 2009 to that in 2011?
Your response must be concise. 0.96. What is the ratio of the Education completion rate(%) in Algeria in 2009 to that in 2011?
Your answer should be very brief. 0.89. What is the ratio of the Education completion rate(%) in Cabo Verde in 2009 to that in 2011?
Your answer should be very brief. 0.95. What is the ratio of the Education completion rate(%) of Least developed countries in 2009 to that in 2012?
Your answer should be compact. 0.95. What is the ratio of the Education completion rate(%) in Algeria in 2009 to that in 2012?
Your answer should be compact. 0.56. What is the ratio of the Education completion rate(%) in Cabo Verde in 2009 to that in 2012?
Make the answer very short. 0.96. What is the ratio of the Education completion rate(%) of Mauritius in 2009 to that in 2012?
Your answer should be very brief. 1.02. What is the ratio of the Education completion rate(%) of Least developed countries in 2009 to that in 2013?
Provide a succinct answer. 0.95. What is the ratio of the Education completion rate(%) of Algeria in 2009 to that in 2013?
Your answer should be compact. 0.72. What is the ratio of the Education completion rate(%) of Cabo Verde in 2009 to that in 2013?
Give a very brief answer. 0.95. What is the ratio of the Education completion rate(%) of Mauritius in 2009 to that in 2013?
Keep it short and to the point. 0.98. What is the ratio of the Education completion rate(%) in Least developed countries in 2010 to that in 2011?
Offer a terse response. 0.97. What is the ratio of the Education completion rate(%) of Algeria in 2010 to that in 2011?
Your answer should be very brief. 0.83. What is the ratio of the Education completion rate(%) in Cabo Verde in 2010 to that in 2011?
Keep it short and to the point. 0.89. What is the ratio of the Education completion rate(%) of Mauritius in 2010 to that in 2011?
Provide a short and direct response. 0.96. What is the ratio of the Education completion rate(%) in Least developed countries in 2010 to that in 2012?
Your answer should be very brief. 0.96. What is the ratio of the Education completion rate(%) of Algeria in 2010 to that in 2012?
Offer a very short reply. 0.53. What is the ratio of the Education completion rate(%) in Cabo Verde in 2010 to that in 2012?
Offer a terse response. 0.9. What is the ratio of the Education completion rate(%) of Mauritius in 2010 to that in 2012?
Your answer should be very brief. 0.99. What is the ratio of the Education completion rate(%) in Least developed countries in 2010 to that in 2013?
Your response must be concise. 0.96. What is the ratio of the Education completion rate(%) of Algeria in 2010 to that in 2013?
Your answer should be compact. 0.67. What is the ratio of the Education completion rate(%) in Cabo Verde in 2010 to that in 2013?
Your answer should be very brief. 0.89. What is the ratio of the Education completion rate(%) of Mauritius in 2010 to that in 2013?
Offer a terse response. 0.96. What is the ratio of the Education completion rate(%) in Algeria in 2011 to that in 2012?
Ensure brevity in your answer.  0.64. What is the ratio of the Education completion rate(%) in Mauritius in 2011 to that in 2012?
Ensure brevity in your answer.  1.04. What is the ratio of the Education completion rate(%) in Least developed countries in 2011 to that in 2013?
Give a very brief answer. 0.99. What is the ratio of the Education completion rate(%) of Algeria in 2011 to that in 2013?
Keep it short and to the point. 0.81. What is the ratio of the Education completion rate(%) in Cabo Verde in 2011 to that in 2013?
Make the answer very short. 1. What is the ratio of the Education completion rate(%) of Mauritius in 2011 to that in 2013?
Keep it short and to the point. 1. What is the ratio of the Education completion rate(%) in Least developed countries in 2012 to that in 2013?
Your answer should be compact. 1. What is the ratio of the Education completion rate(%) in Algeria in 2012 to that in 2013?
Make the answer very short. 1.27. What is the ratio of the Education completion rate(%) of Mauritius in 2012 to that in 2013?
Your answer should be compact. 0.97. What is the difference between the highest and the second highest Education completion rate(%) in Least developed countries?
Your answer should be compact. 0.06. What is the difference between the highest and the second highest Education completion rate(%) of Algeria?
Make the answer very short. 19.76. What is the difference between the highest and the second highest Education completion rate(%) of Cabo Verde?
Keep it short and to the point. 0.08. What is the difference between the highest and the second highest Education completion rate(%) of Mauritius?
Keep it short and to the point. 0.35. What is the difference between the highest and the lowest Education completion rate(%) of Least developed countries?
Make the answer very short. 4.91. What is the difference between the highest and the lowest Education completion rate(%) in Algeria?
Keep it short and to the point. 47.89. What is the difference between the highest and the lowest Education completion rate(%) in Cabo Verde?
Your answer should be very brief. 8.68. What is the difference between the highest and the lowest Education completion rate(%) in Mauritius?
Your answer should be compact. 6.08. 